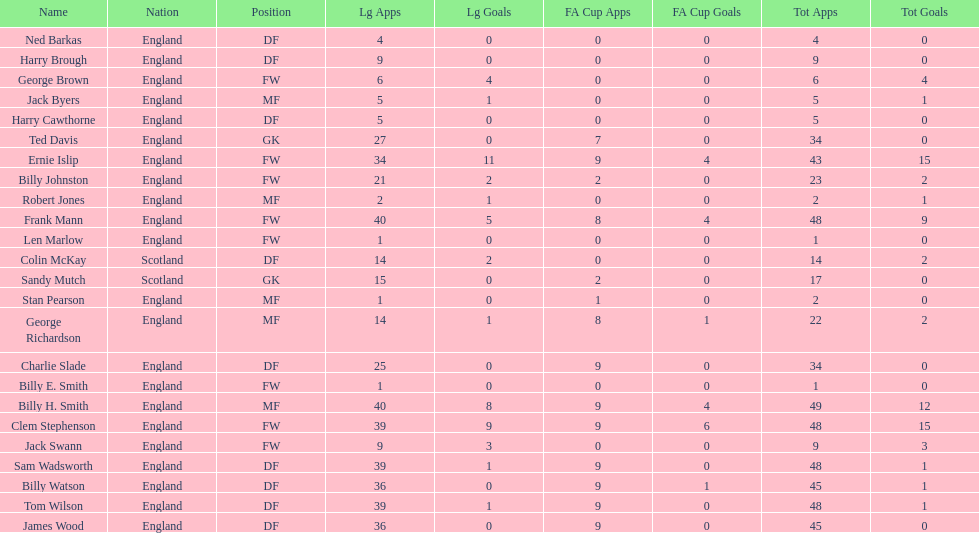What is the average number of scotland's total apps? 15.5. 